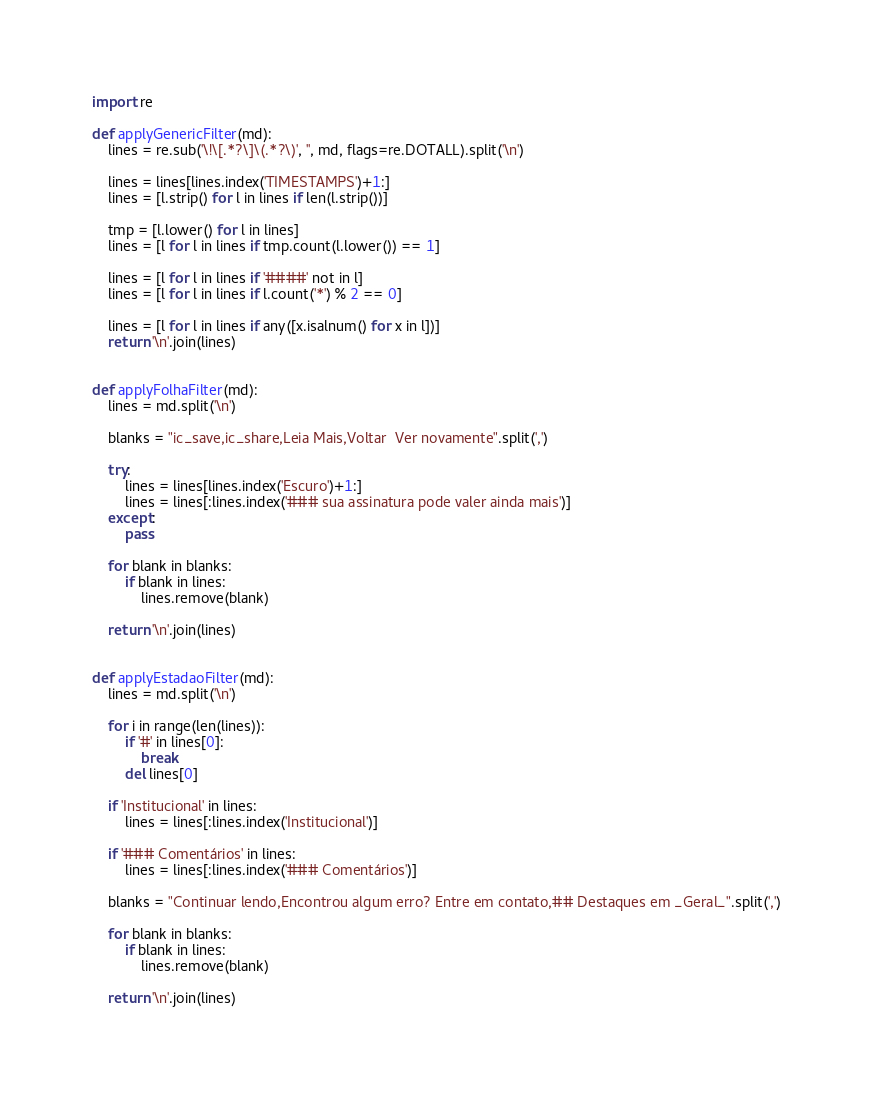<code> <loc_0><loc_0><loc_500><loc_500><_Python_>import re

def applyGenericFilter(md):
	lines = re.sub('\!\[.*?\]\(.*?\)', '', md, flags=re.DOTALL).split('\n')

	lines = lines[lines.index('TIMESTAMPS')+1:]
	lines = [l.strip() for l in lines if len(l.strip())]

	tmp = [l.lower() for l in lines]
	lines = [l for l in lines if tmp.count(l.lower()) == 1]

	lines = [l for l in lines if '####' not in l]
	lines = [l for l in lines if l.count('*') % 2 == 0]

	lines = [l for l in lines if any([x.isalnum() for x in l])]
	return '\n'.join(lines)


def applyFolhaFilter(md):
	lines = md.split('\n')

	blanks = "ic_save,ic_share,Leia Mais,Voltar  Ver novamente".split(',')

	try:
		lines = lines[lines.index('Escuro')+1:]
		lines = lines[:lines.index('### sua assinatura pode valer ainda mais')]
	except:
		pass

	for blank in blanks:
		if blank in lines:
			lines.remove(blank)
	
	return '\n'.join(lines)


def applyEstadaoFilter(md):
	lines = md.split('\n')

	for i in range(len(lines)):
		if '#' in lines[0]:
			break
		del lines[0]

	if 'Institucional' in lines:
		lines = lines[:lines.index('Institucional')]

	if '### Comentários' in lines:
		lines = lines[:lines.index('### Comentários')]

	blanks = "Continuar lendo,Encontrou algum erro? Entre em contato,## Destaques em _Geral_".split(',')

	for blank in blanks:
		if blank in lines:
			lines.remove(blank)

	return '\n'.join(lines)</code> 